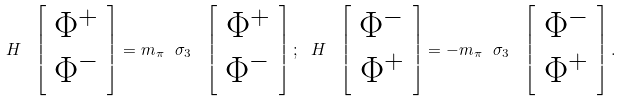<formula> <loc_0><loc_0><loc_500><loc_500>H \ \left [ \begin{array} { c } \Phi ^ { + } \\ \Phi ^ { - } \end{array} \right ] = m _ { \pi } \ \sigma _ { 3 } \ \left [ \begin{array} { c } \Phi ^ { + } \\ \Phi ^ { - } \end{array} \right ] ; \ H \ \left [ \begin{array} { c } \Phi ^ { - } \\ \Phi ^ { + } \end{array} \right ] = - m _ { \pi } \ \sigma _ { 3 } \ \left [ \begin{array} { c } \Phi ^ { - } \\ \Phi ^ { + } \end{array} \right ] .</formula> 